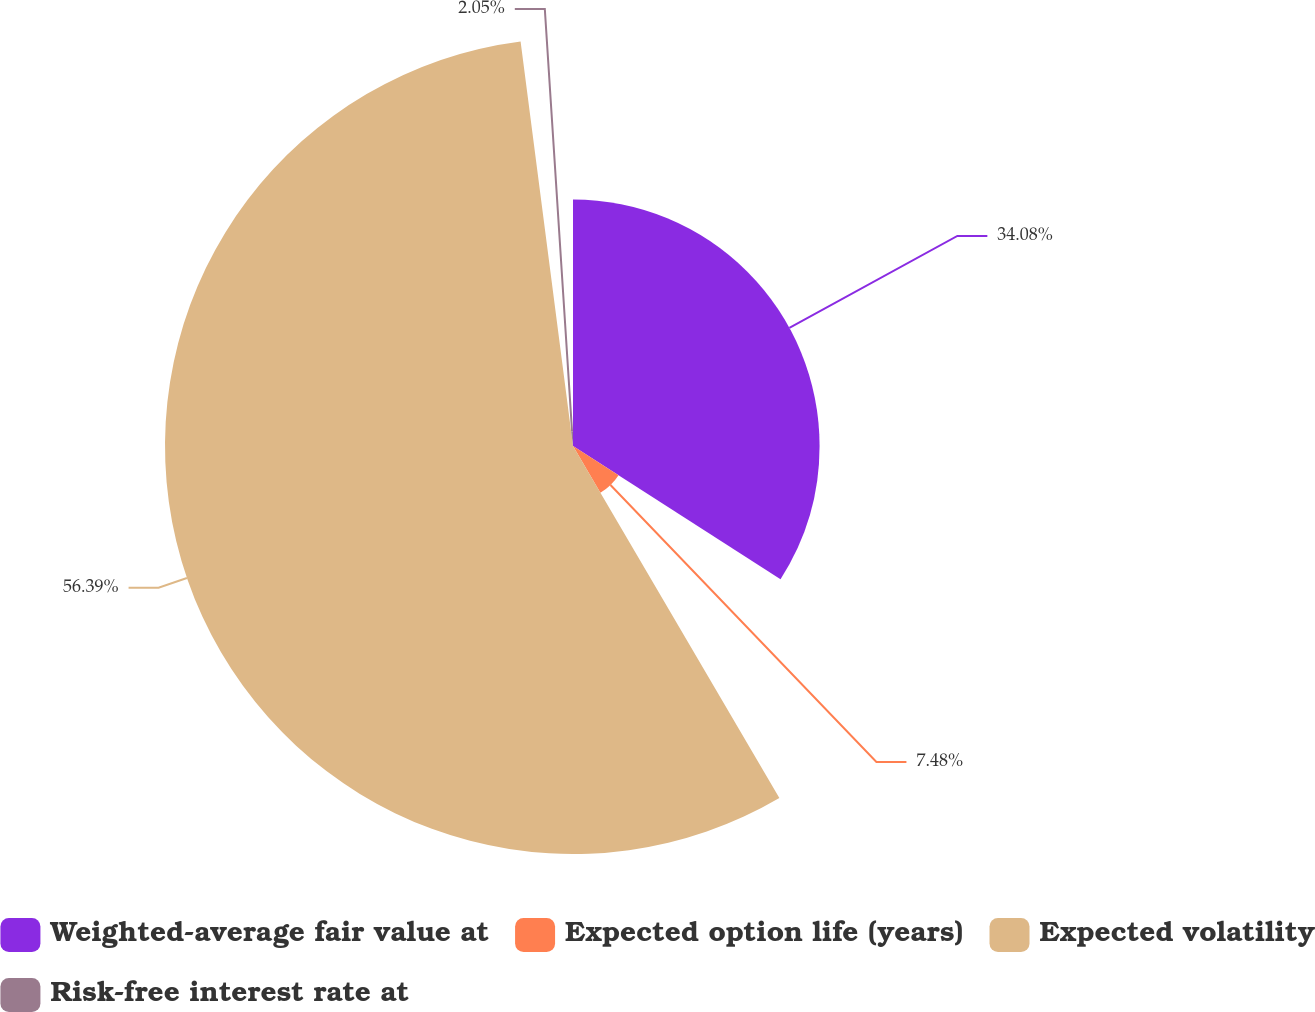Convert chart. <chart><loc_0><loc_0><loc_500><loc_500><pie_chart><fcel>Weighted-average fair value at<fcel>Expected option life (years)<fcel>Expected volatility<fcel>Risk-free interest rate at<nl><fcel>34.08%<fcel>7.48%<fcel>56.39%<fcel>2.05%<nl></chart> 